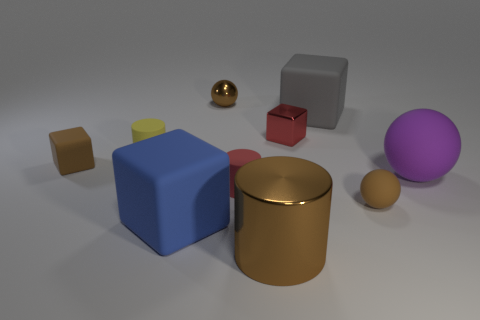There is a big blue rubber object; are there any large blue matte objects behind it?
Your response must be concise. No. Is there a blue thing of the same size as the blue cube?
Provide a short and direct response. No. There is a large ball that is made of the same material as the gray cube; what is its color?
Make the answer very short. Purple. What is the material of the purple object?
Offer a terse response. Rubber. What is the shape of the tiny red rubber object?
Offer a terse response. Cylinder. How many tiny rubber balls are the same color as the tiny shiny sphere?
Provide a short and direct response. 1. There is a brown sphere that is behind the tiny brown rubber object that is on the left side of the tiny cylinder that is behind the big rubber ball; what is it made of?
Keep it short and to the point. Metal. What number of blue objects are metallic blocks or tiny rubber spheres?
Offer a terse response. 0. There is a matte cylinder that is right of the brown ball behind the brown rubber thing right of the tiny brown block; what size is it?
Give a very brief answer. Small. There is a brown metal thing that is the same shape as the big purple object; what is its size?
Your response must be concise. Small. 